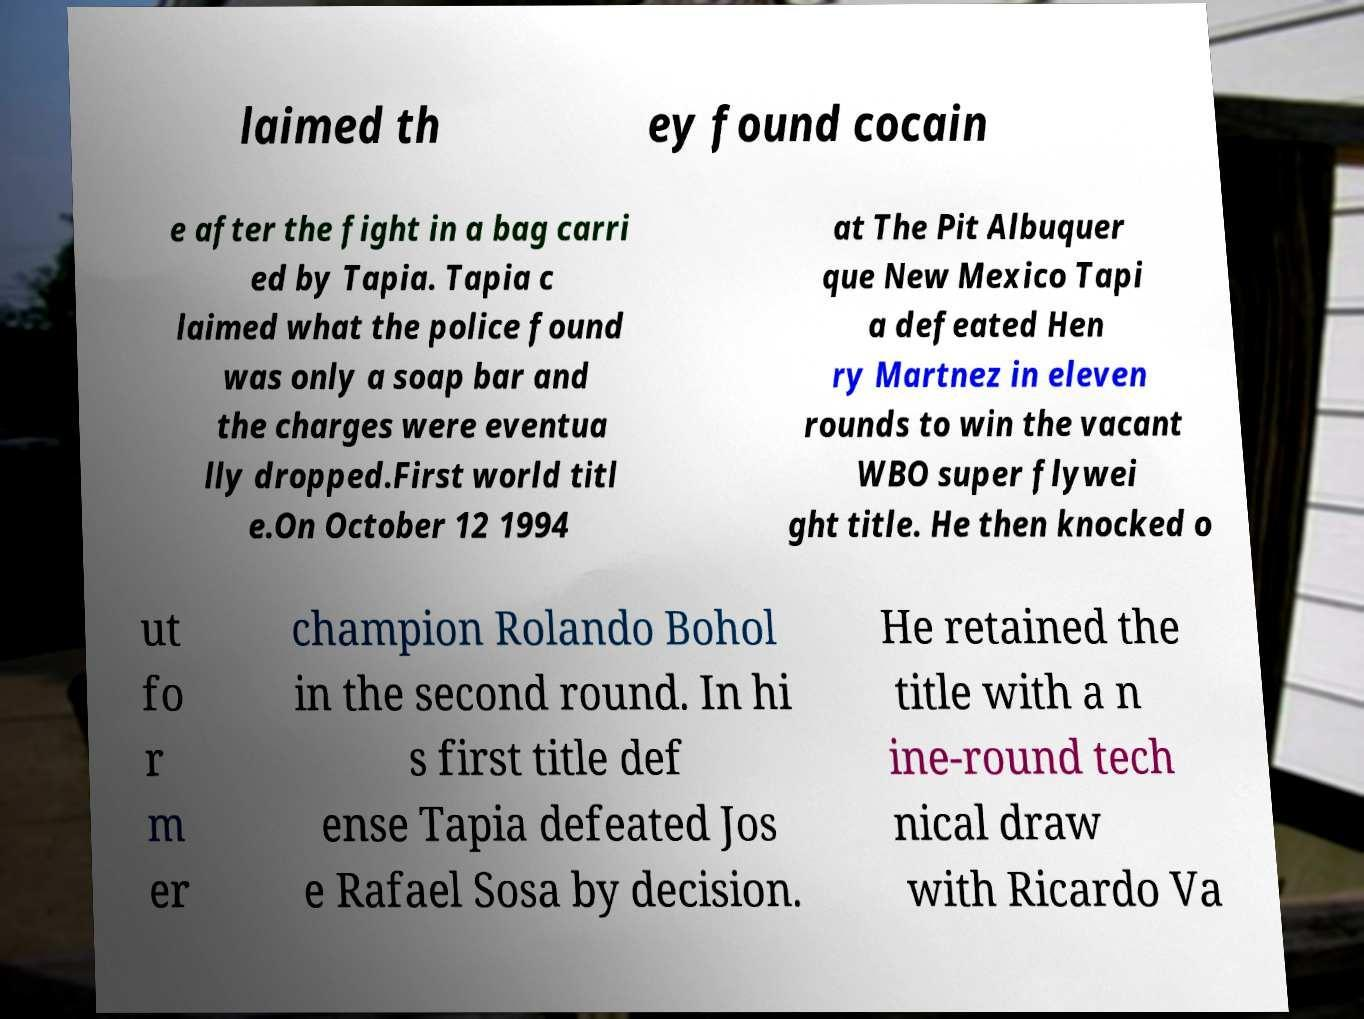For documentation purposes, I need the text within this image transcribed. Could you provide that? laimed th ey found cocain e after the fight in a bag carri ed by Tapia. Tapia c laimed what the police found was only a soap bar and the charges were eventua lly dropped.First world titl e.On October 12 1994 at The Pit Albuquer que New Mexico Tapi a defeated Hen ry Martnez in eleven rounds to win the vacant WBO super flywei ght title. He then knocked o ut fo r m er champion Rolando Bohol in the second round. In hi s first title def ense Tapia defeated Jos e Rafael Sosa by decision. He retained the title with a n ine-round tech nical draw with Ricardo Va 